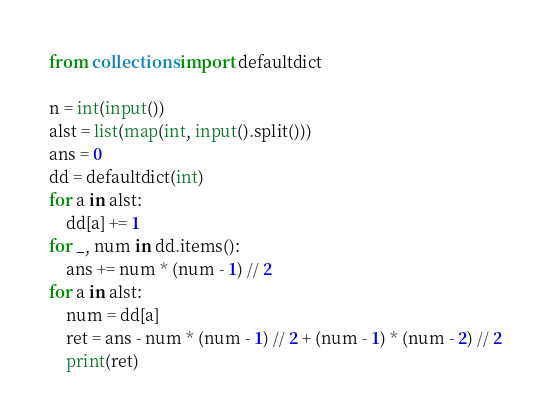<code> <loc_0><loc_0><loc_500><loc_500><_Python_>from collections import defaultdict

n = int(input())
alst = list(map(int, input().split()))
ans = 0
dd = defaultdict(int)
for a in alst:
    dd[a] += 1
for _, num in dd.items():
    ans += num * (num - 1) // 2
for a in alst:
    num = dd[a]
    ret = ans - num * (num - 1) // 2 + (num - 1) * (num - 2) // 2
    print(ret)</code> 